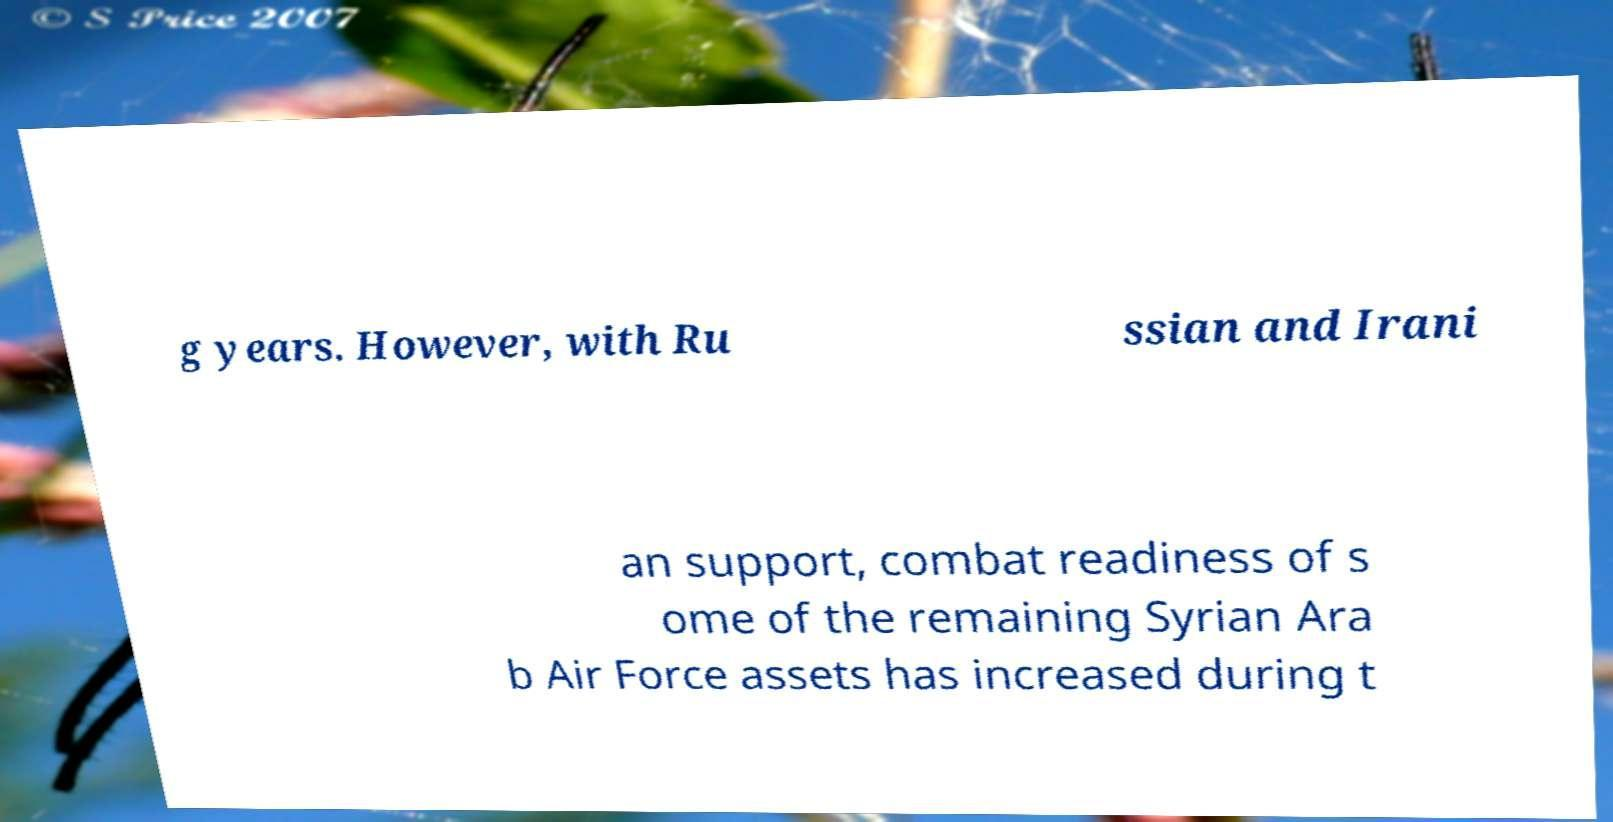What messages or text are displayed in this image? I need them in a readable, typed format. g years. However, with Ru ssian and Irani an support, combat readiness of s ome of the remaining Syrian Ara b Air Force assets has increased during t 